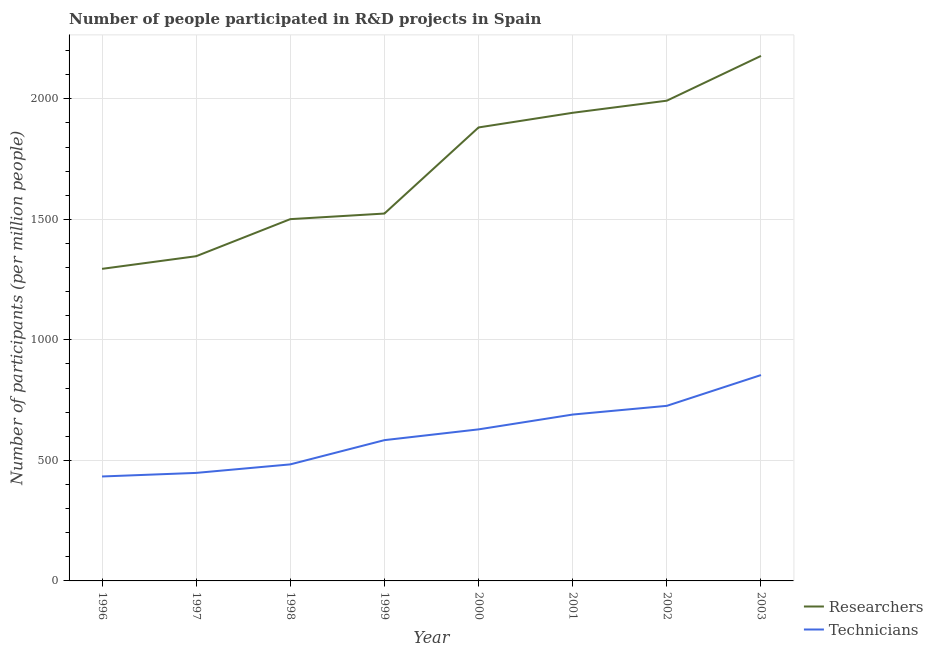How many different coloured lines are there?
Keep it short and to the point. 2. What is the number of technicians in 1999?
Your response must be concise. 584.09. Across all years, what is the maximum number of technicians?
Offer a terse response. 854.09. Across all years, what is the minimum number of researchers?
Keep it short and to the point. 1294.75. In which year was the number of technicians maximum?
Keep it short and to the point. 2003. What is the total number of researchers in the graph?
Your response must be concise. 1.37e+04. What is the difference between the number of researchers in 2001 and that in 2002?
Your response must be concise. -50.25. What is the difference between the number of technicians in 2002 and the number of researchers in 1996?
Your answer should be compact. -568.31. What is the average number of researchers per year?
Offer a very short reply. 1707.72. In the year 2003, what is the difference between the number of technicians and number of researchers?
Your answer should be very brief. -1324.18. What is the ratio of the number of technicians in 1997 to that in 1999?
Keep it short and to the point. 0.77. Is the difference between the number of researchers in 1998 and 1999 greater than the difference between the number of technicians in 1998 and 1999?
Keep it short and to the point. Yes. What is the difference between the highest and the second highest number of technicians?
Offer a terse response. 127.66. What is the difference between the highest and the lowest number of researchers?
Your response must be concise. 883.53. In how many years, is the number of researchers greater than the average number of researchers taken over all years?
Ensure brevity in your answer.  4. Does the number of technicians monotonically increase over the years?
Your answer should be very brief. Yes. Is the number of technicians strictly greater than the number of researchers over the years?
Your answer should be compact. No. Is the number of researchers strictly less than the number of technicians over the years?
Keep it short and to the point. No. What is the difference between two consecutive major ticks on the Y-axis?
Offer a terse response. 500. Where does the legend appear in the graph?
Provide a short and direct response. Bottom right. How are the legend labels stacked?
Provide a short and direct response. Vertical. What is the title of the graph?
Your answer should be compact. Number of people participated in R&D projects in Spain. What is the label or title of the X-axis?
Ensure brevity in your answer.  Year. What is the label or title of the Y-axis?
Your answer should be compact. Number of participants (per million people). What is the Number of participants (per million people) in Researchers in 1996?
Provide a short and direct response. 1294.75. What is the Number of participants (per million people) of Technicians in 1996?
Offer a very short reply. 433.34. What is the Number of participants (per million people) of Researchers in 1997?
Your response must be concise. 1347.2. What is the Number of participants (per million people) in Technicians in 1997?
Provide a succinct answer. 448.17. What is the Number of participants (per million people) in Researchers in 1998?
Your response must be concise. 1501.03. What is the Number of participants (per million people) of Technicians in 1998?
Give a very brief answer. 483.52. What is the Number of participants (per million people) in Researchers in 1999?
Ensure brevity in your answer.  1524.24. What is the Number of participants (per million people) of Technicians in 1999?
Your answer should be very brief. 584.09. What is the Number of participants (per million people) in Researchers in 2000?
Offer a very short reply. 1881.47. What is the Number of participants (per million people) in Technicians in 2000?
Provide a short and direct response. 628.77. What is the Number of participants (per million people) of Researchers in 2001?
Provide a short and direct response. 1942.27. What is the Number of participants (per million people) of Technicians in 2001?
Your response must be concise. 690.27. What is the Number of participants (per million people) in Researchers in 2002?
Your response must be concise. 1992.51. What is the Number of participants (per million people) of Technicians in 2002?
Offer a terse response. 726.43. What is the Number of participants (per million people) of Researchers in 2003?
Keep it short and to the point. 2178.27. What is the Number of participants (per million people) of Technicians in 2003?
Provide a succinct answer. 854.09. Across all years, what is the maximum Number of participants (per million people) in Researchers?
Your answer should be compact. 2178.27. Across all years, what is the maximum Number of participants (per million people) of Technicians?
Offer a terse response. 854.09. Across all years, what is the minimum Number of participants (per million people) of Researchers?
Provide a short and direct response. 1294.75. Across all years, what is the minimum Number of participants (per million people) of Technicians?
Your response must be concise. 433.34. What is the total Number of participants (per million people) in Researchers in the graph?
Give a very brief answer. 1.37e+04. What is the total Number of participants (per million people) in Technicians in the graph?
Your response must be concise. 4848.68. What is the difference between the Number of participants (per million people) in Researchers in 1996 and that in 1997?
Give a very brief answer. -52.46. What is the difference between the Number of participants (per million people) of Technicians in 1996 and that in 1997?
Ensure brevity in your answer.  -14.83. What is the difference between the Number of participants (per million people) in Researchers in 1996 and that in 1998?
Your response must be concise. -206.29. What is the difference between the Number of participants (per million people) of Technicians in 1996 and that in 1998?
Your response must be concise. -50.18. What is the difference between the Number of participants (per million people) of Researchers in 1996 and that in 1999?
Make the answer very short. -229.49. What is the difference between the Number of participants (per million people) in Technicians in 1996 and that in 1999?
Provide a short and direct response. -150.76. What is the difference between the Number of participants (per million people) of Researchers in 1996 and that in 2000?
Make the answer very short. -586.73. What is the difference between the Number of participants (per million people) of Technicians in 1996 and that in 2000?
Offer a terse response. -195.44. What is the difference between the Number of participants (per million people) of Researchers in 1996 and that in 2001?
Your response must be concise. -647.52. What is the difference between the Number of participants (per million people) in Technicians in 1996 and that in 2001?
Keep it short and to the point. -256.93. What is the difference between the Number of participants (per million people) of Researchers in 1996 and that in 2002?
Offer a very short reply. -697.77. What is the difference between the Number of participants (per million people) in Technicians in 1996 and that in 2002?
Your answer should be very brief. -293.1. What is the difference between the Number of participants (per million people) of Researchers in 1996 and that in 2003?
Ensure brevity in your answer.  -883.53. What is the difference between the Number of participants (per million people) in Technicians in 1996 and that in 2003?
Offer a terse response. -420.76. What is the difference between the Number of participants (per million people) of Researchers in 1997 and that in 1998?
Give a very brief answer. -153.83. What is the difference between the Number of participants (per million people) in Technicians in 1997 and that in 1998?
Your answer should be compact. -35.35. What is the difference between the Number of participants (per million people) in Researchers in 1997 and that in 1999?
Give a very brief answer. -177.04. What is the difference between the Number of participants (per million people) in Technicians in 1997 and that in 1999?
Give a very brief answer. -135.93. What is the difference between the Number of participants (per million people) of Researchers in 1997 and that in 2000?
Give a very brief answer. -534.27. What is the difference between the Number of participants (per million people) of Technicians in 1997 and that in 2000?
Ensure brevity in your answer.  -180.61. What is the difference between the Number of participants (per million people) in Researchers in 1997 and that in 2001?
Provide a short and direct response. -595.06. What is the difference between the Number of participants (per million people) of Technicians in 1997 and that in 2001?
Ensure brevity in your answer.  -242.1. What is the difference between the Number of participants (per million people) of Researchers in 1997 and that in 2002?
Your response must be concise. -645.31. What is the difference between the Number of participants (per million people) of Technicians in 1997 and that in 2002?
Your response must be concise. -278.27. What is the difference between the Number of participants (per million people) of Researchers in 1997 and that in 2003?
Give a very brief answer. -831.07. What is the difference between the Number of participants (per million people) in Technicians in 1997 and that in 2003?
Ensure brevity in your answer.  -405.93. What is the difference between the Number of participants (per million people) in Researchers in 1998 and that in 1999?
Ensure brevity in your answer.  -23.21. What is the difference between the Number of participants (per million people) in Technicians in 1998 and that in 1999?
Make the answer very short. -100.58. What is the difference between the Number of participants (per million people) in Researchers in 1998 and that in 2000?
Give a very brief answer. -380.44. What is the difference between the Number of participants (per million people) of Technicians in 1998 and that in 2000?
Keep it short and to the point. -145.26. What is the difference between the Number of participants (per million people) of Researchers in 1998 and that in 2001?
Your answer should be very brief. -441.23. What is the difference between the Number of participants (per million people) in Technicians in 1998 and that in 2001?
Offer a terse response. -206.75. What is the difference between the Number of participants (per million people) in Researchers in 1998 and that in 2002?
Make the answer very short. -491.48. What is the difference between the Number of participants (per million people) in Technicians in 1998 and that in 2002?
Your answer should be compact. -242.92. What is the difference between the Number of participants (per million people) of Researchers in 1998 and that in 2003?
Ensure brevity in your answer.  -677.24. What is the difference between the Number of participants (per million people) in Technicians in 1998 and that in 2003?
Your response must be concise. -370.58. What is the difference between the Number of participants (per million people) of Researchers in 1999 and that in 2000?
Keep it short and to the point. -357.23. What is the difference between the Number of participants (per million people) in Technicians in 1999 and that in 2000?
Your response must be concise. -44.68. What is the difference between the Number of participants (per million people) of Researchers in 1999 and that in 2001?
Ensure brevity in your answer.  -418.02. What is the difference between the Number of participants (per million people) of Technicians in 1999 and that in 2001?
Give a very brief answer. -106.17. What is the difference between the Number of participants (per million people) of Researchers in 1999 and that in 2002?
Offer a terse response. -468.27. What is the difference between the Number of participants (per million people) in Technicians in 1999 and that in 2002?
Your answer should be very brief. -142.34. What is the difference between the Number of participants (per million people) in Researchers in 1999 and that in 2003?
Make the answer very short. -654.03. What is the difference between the Number of participants (per million people) in Technicians in 1999 and that in 2003?
Keep it short and to the point. -270. What is the difference between the Number of participants (per million people) in Researchers in 2000 and that in 2001?
Offer a terse response. -60.79. What is the difference between the Number of participants (per million people) of Technicians in 2000 and that in 2001?
Your answer should be very brief. -61.49. What is the difference between the Number of participants (per million people) of Researchers in 2000 and that in 2002?
Your answer should be compact. -111.04. What is the difference between the Number of participants (per million people) in Technicians in 2000 and that in 2002?
Your answer should be compact. -97.66. What is the difference between the Number of participants (per million people) in Researchers in 2000 and that in 2003?
Offer a terse response. -296.8. What is the difference between the Number of participants (per million people) of Technicians in 2000 and that in 2003?
Provide a succinct answer. -225.32. What is the difference between the Number of participants (per million people) in Researchers in 2001 and that in 2002?
Keep it short and to the point. -50.25. What is the difference between the Number of participants (per million people) of Technicians in 2001 and that in 2002?
Keep it short and to the point. -36.17. What is the difference between the Number of participants (per million people) of Researchers in 2001 and that in 2003?
Your answer should be very brief. -236.01. What is the difference between the Number of participants (per million people) in Technicians in 2001 and that in 2003?
Provide a short and direct response. -163.83. What is the difference between the Number of participants (per million people) in Researchers in 2002 and that in 2003?
Provide a succinct answer. -185.76. What is the difference between the Number of participants (per million people) of Technicians in 2002 and that in 2003?
Make the answer very short. -127.66. What is the difference between the Number of participants (per million people) of Researchers in 1996 and the Number of participants (per million people) of Technicians in 1997?
Give a very brief answer. 846.58. What is the difference between the Number of participants (per million people) of Researchers in 1996 and the Number of participants (per million people) of Technicians in 1998?
Keep it short and to the point. 811.23. What is the difference between the Number of participants (per million people) in Researchers in 1996 and the Number of participants (per million people) in Technicians in 1999?
Provide a short and direct response. 710.65. What is the difference between the Number of participants (per million people) of Researchers in 1996 and the Number of participants (per million people) of Technicians in 2000?
Make the answer very short. 665.97. What is the difference between the Number of participants (per million people) of Researchers in 1996 and the Number of participants (per million people) of Technicians in 2001?
Provide a short and direct response. 604.48. What is the difference between the Number of participants (per million people) in Researchers in 1996 and the Number of participants (per million people) in Technicians in 2002?
Give a very brief answer. 568.31. What is the difference between the Number of participants (per million people) of Researchers in 1996 and the Number of participants (per million people) of Technicians in 2003?
Keep it short and to the point. 440.65. What is the difference between the Number of participants (per million people) of Researchers in 1997 and the Number of participants (per million people) of Technicians in 1998?
Give a very brief answer. 863.69. What is the difference between the Number of participants (per million people) of Researchers in 1997 and the Number of participants (per million people) of Technicians in 1999?
Your answer should be very brief. 763.11. What is the difference between the Number of participants (per million people) in Researchers in 1997 and the Number of participants (per million people) in Technicians in 2000?
Give a very brief answer. 718.43. What is the difference between the Number of participants (per million people) in Researchers in 1997 and the Number of participants (per million people) in Technicians in 2001?
Ensure brevity in your answer.  656.94. What is the difference between the Number of participants (per million people) of Researchers in 1997 and the Number of participants (per million people) of Technicians in 2002?
Your response must be concise. 620.77. What is the difference between the Number of participants (per million people) of Researchers in 1997 and the Number of participants (per million people) of Technicians in 2003?
Your response must be concise. 493.11. What is the difference between the Number of participants (per million people) in Researchers in 1998 and the Number of participants (per million people) in Technicians in 1999?
Your answer should be very brief. 916.94. What is the difference between the Number of participants (per million people) in Researchers in 1998 and the Number of participants (per million people) in Technicians in 2000?
Provide a succinct answer. 872.26. What is the difference between the Number of participants (per million people) in Researchers in 1998 and the Number of participants (per million people) in Technicians in 2001?
Provide a short and direct response. 810.77. What is the difference between the Number of participants (per million people) of Researchers in 1998 and the Number of participants (per million people) of Technicians in 2002?
Your answer should be very brief. 774.6. What is the difference between the Number of participants (per million people) of Researchers in 1998 and the Number of participants (per million people) of Technicians in 2003?
Keep it short and to the point. 646.94. What is the difference between the Number of participants (per million people) of Researchers in 1999 and the Number of participants (per million people) of Technicians in 2000?
Offer a terse response. 895.47. What is the difference between the Number of participants (per million people) of Researchers in 1999 and the Number of participants (per million people) of Technicians in 2001?
Offer a very short reply. 833.97. What is the difference between the Number of participants (per million people) in Researchers in 1999 and the Number of participants (per million people) in Technicians in 2002?
Your answer should be compact. 797.81. What is the difference between the Number of participants (per million people) of Researchers in 1999 and the Number of participants (per million people) of Technicians in 2003?
Keep it short and to the point. 670.15. What is the difference between the Number of participants (per million people) of Researchers in 2000 and the Number of participants (per million people) of Technicians in 2001?
Offer a terse response. 1191.21. What is the difference between the Number of participants (per million people) of Researchers in 2000 and the Number of participants (per million people) of Technicians in 2002?
Provide a short and direct response. 1155.04. What is the difference between the Number of participants (per million people) of Researchers in 2000 and the Number of participants (per million people) of Technicians in 2003?
Keep it short and to the point. 1027.38. What is the difference between the Number of participants (per million people) in Researchers in 2001 and the Number of participants (per million people) in Technicians in 2002?
Make the answer very short. 1215.83. What is the difference between the Number of participants (per million people) in Researchers in 2001 and the Number of participants (per million people) in Technicians in 2003?
Make the answer very short. 1088.17. What is the difference between the Number of participants (per million people) of Researchers in 2002 and the Number of participants (per million people) of Technicians in 2003?
Give a very brief answer. 1138.42. What is the average Number of participants (per million people) in Researchers per year?
Your response must be concise. 1707.72. What is the average Number of participants (per million people) of Technicians per year?
Provide a short and direct response. 606.08. In the year 1996, what is the difference between the Number of participants (per million people) of Researchers and Number of participants (per million people) of Technicians?
Make the answer very short. 861.41. In the year 1997, what is the difference between the Number of participants (per million people) in Researchers and Number of participants (per million people) in Technicians?
Provide a succinct answer. 899.03. In the year 1998, what is the difference between the Number of participants (per million people) of Researchers and Number of participants (per million people) of Technicians?
Your response must be concise. 1017.52. In the year 1999, what is the difference between the Number of participants (per million people) of Researchers and Number of participants (per million people) of Technicians?
Make the answer very short. 940.15. In the year 2000, what is the difference between the Number of participants (per million people) of Researchers and Number of participants (per million people) of Technicians?
Your answer should be very brief. 1252.7. In the year 2001, what is the difference between the Number of participants (per million people) of Researchers and Number of participants (per million people) of Technicians?
Your response must be concise. 1252. In the year 2002, what is the difference between the Number of participants (per million people) in Researchers and Number of participants (per million people) in Technicians?
Your answer should be compact. 1266.08. In the year 2003, what is the difference between the Number of participants (per million people) of Researchers and Number of participants (per million people) of Technicians?
Ensure brevity in your answer.  1324.18. What is the ratio of the Number of participants (per million people) in Researchers in 1996 to that in 1997?
Keep it short and to the point. 0.96. What is the ratio of the Number of participants (per million people) in Technicians in 1996 to that in 1997?
Provide a short and direct response. 0.97. What is the ratio of the Number of participants (per million people) in Researchers in 1996 to that in 1998?
Your answer should be compact. 0.86. What is the ratio of the Number of participants (per million people) of Technicians in 1996 to that in 1998?
Provide a short and direct response. 0.9. What is the ratio of the Number of participants (per million people) of Researchers in 1996 to that in 1999?
Your answer should be very brief. 0.85. What is the ratio of the Number of participants (per million people) of Technicians in 1996 to that in 1999?
Offer a very short reply. 0.74. What is the ratio of the Number of participants (per million people) in Researchers in 1996 to that in 2000?
Provide a succinct answer. 0.69. What is the ratio of the Number of participants (per million people) in Technicians in 1996 to that in 2000?
Give a very brief answer. 0.69. What is the ratio of the Number of participants (per million people) of Researchers in 1996 to that in 2001?
Provide a short and direct response. 0.67. What is the ratio of the Number of participants (per million people) of Technicians in 1996 to that in 2001?
Your answer should be very brief. 0.63. What is the ratio of the Number of participants (per million people) in Researchers in 1996 to that in 2002?
Keep it short and to the point. 0.65. What is the ratio of the Number of participants (per million people) in Technicians in 1996 to that in 2002?
Offer a very short reply. 0.6. What is the ratio of the Number of participants (per million people) of Researchers in 1996 to that in 2003?
Keep it short and to the point. 0.59. What is the ratio of the Number of participants (per million people) of Technicians in 1996 to that in 2003?
Your response must be concise. 0.51. What is the ratio of the Number of participants (per million people) in Researchers in 1997 to that in 1998?
Your response must be concise. 0.9. What is the ratio of the Number of participants (per million people) in Technicians in 1997 to that in 1998?
Your response must be concise. 0.93. What is the ratio of the Number of participants (per million people) in Researchers in 1997 to that in 1999?
Your response must be concise. 0.88. What is the ratio of the Number of participants (per million people) of Technicians in 1997 to that in 1999?
Provide a short and direct response. 0.77. What is the ratio of the Number of participants (per million people) of Researchers in 1997 to that in 2000?
Provide a short and direct response. 0.72. What is the ratio of the Number of participants (per million people) of Technicians in 1997 to that in 2000?
Provide a short and direct response. 0.71. What is the ratio of the Number of participants (per million people) of Researchers in 1997 to that in 2001?
Offer a very short reply. 0.69. What is the ratio of the Number of participants (per million people) in Technicians in 1997 to that in 2001?
Provide a short and direct response. 0.65. What is the ratio of the Number of participants (per million people) in Researchers in 1997 to that in 2002?
Keep it short and to the point. 0.68. What is the ratio of the Number of participants (per million people) of Technicians in 1997 to that in 2002?
Make the answer very short. 0.62. What is the ratio of the Number of participants (per million people) of Researchers in 1997 to that in 2003?
Provide a succinct answer. 0.62. What is the ratio of the Number of participants (per million people) of Technicians in 1997 to that in 2003?
Give a very brief answer. 0.52. What is the ratio of the Number of participants (per million people) of Researchers in 1998 to that in 1999?
Your answer should be compact. 0.98. What is the ratio of the Number of participants (per million people) in Technicians in 1998 to that in 1999?
Your answer should be compact. 0.83. What is the ratio of the Number of participants (per million people) in Researchers in 1998 to that in 2000?
Your answer should be very brief. 0.8. What is the ratio of the Number of participants (per million people) of Technicians in 1998 to that in 2000?
Make the answer very short. 0.77. What is the ratio of the Number of participants (per million people) in Researchers in 1998 to that in 2001?
Offer a terse response. 0.77. What is the ratio of the Number of participants (per million people) of Technicians in 1998 to that in 2001?
Your answer should be compact. 0.7. What is the ratio of the Number of participants (per million people) of Researchers in 1998 to that in 2002?
Offer a very short reply. 0.75. What is the ratio of the Number of participants (per million people) in Technicians in 1998 to that in 2002?
Make the answer very short. 0.67. What is the ratio of the Number of participants (per million people) in Researchers in 1998 to that in 2003?
Keep it short and to the point. 0.69. What is the ratio of the Number of participants (per million people) in Technicians in 1998 to that in 2003?
Your answer should be compact. 0.57. What is the ratio of the Number of participants (per million people) of Researchers in 1999 to that in 2000?
Offer a very short reply. 0.81. What is the ratio of the Number of participants (per million people) in Technicians in 1999 to that in 2000?
Your answer should be very brief. 0.93. What is the ratio of the Number of participants (per million people) of Researchers in 1999 to that in 2001?
Ensure brevity in your answer.  0.78. What is the ratio of the Number of participants (per million people) of Technicians in 1999 to that in 2001?
Ensure brevity in your answer.  0.85. What is the ratio of the Number of participants (per million people) in Researchers in 1999 to that in 2002?
Provide a succinct answer. 0.77. What is the ratio of the Number of participants (per million people) of Technicians in 1999 to that in 2002?
Make the answer very short. 0.8. What is the ratio of the Number of participants (per million people) in Researchers in 1999 to that in 2003?
Your answer should be compact. 0.7. What is the ratio of the Number of participants (per million people) in Technicians in 1999 to that in 2003?
Make the answer very short. 0.68. What is the ratio of the Number of participants (per million people) in Researchers in 2000 to that in 2001?
Offer a terse response. 0.97. What is the ratio of the Number of participants (per million people) of Technicians in 2000 to that in 2001?
Keep it short and to the point. 0.91. What is the ratio of the Number of participants (per million people) of Researchers in 2000 to that in 2002?
Make the answer very short. 0.94. What is the ratio of the Number of participants (per million people) of Technicians in 2000 to that in 2002?
Your answer should be compact. 0.87. What is the ratio of the Number of participants (per million people) of Researchers in 2000 to that in 2003?
Offer a very short reply. 0.86. What is the ratio of the Number of participants (per million people) of Technicians in 2000 to that in 2003?
Give a very brief answer. 0.74. What is the ratio of the Number of participants (per million people) in Researchers in 2001 to that in 2002?
Make the answer very short. 0.97. What is the ratio of the Number of participants (per million people) in Technicians in 2001 to that in 2002?
Make the answer very short. 0.95. What is the ratio of the Number of participants (per million people) in Researchers in 2001 to that in 2003?
Make the answer very short. 0.89. What is the ratio of the Number of participants (per million people) of Technicians in 2001 to that in 2003?
Provide a short and direct response. 0.81. What is the ratio of the Number of participants (per million people) of Researchers in 2002 to that in 2003?
Give a very brief answer. 0.91. What is the ratio of the Number of participants (per million people) in Technicians in 2002 to that in 2003?
Your answer should be very brief. 0.85. What is the difference between the highest and the second highest Number of participants (per million people) in Researchers?
Provide a succinct answer. 185.76. What is the difference between the highest and the second highest Number of participants (per million people) in Technicians?
Ensure brevity in your answer.  127.66. What is the difference between the highest and the lowest Number of participants (per million people) in Researchers?
Offer a terse response. 883.53. What is the difference between the highest and the lowest Number of participants (per million people) of Technicians?
Ensure brevity in your answer.  420.76. 